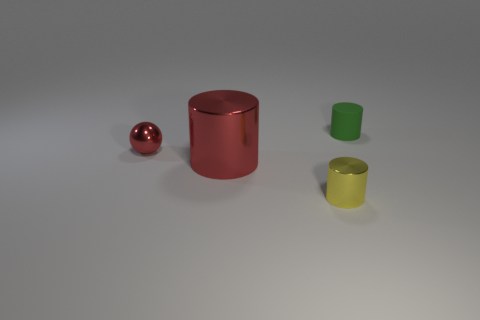Is there anything else that is the same size as the red cylinder?
Keep it short and to the point. No. Is there a small thing of the same color as the small metal cylinder?
Give a very brief answer. No. Is the large thing the same color as the tiny ball?
Your answer should be compact. Yes. What material is the ball that is the same color as the large object?
Keep it short and to the point. Metal. There is a tiny thing left of the small cylinder left of the thing that is to the right of the tiny yellow thing; what is its material?
Make the answer very short. Metal. What is the size of the metal thing that is the same color as the shiny sphere?
Keep it short and to the point. Large. What is the material of the tiny yellow thing?
Offer a terse response. Metal. Does the yellow thing have the same material as the small object that is behind the tiny red metal sphere?
Make the answer very short. No. There is a tiny thing in front of the red metal thing to the left of the large cylinder; what is its color?
Provide a succinct answer. Yellow. There is a thing that is both in front of the green rubber thing and behind the big red shiny cylinder; how big is it?
Ensure brevity in your answer.  Small. 